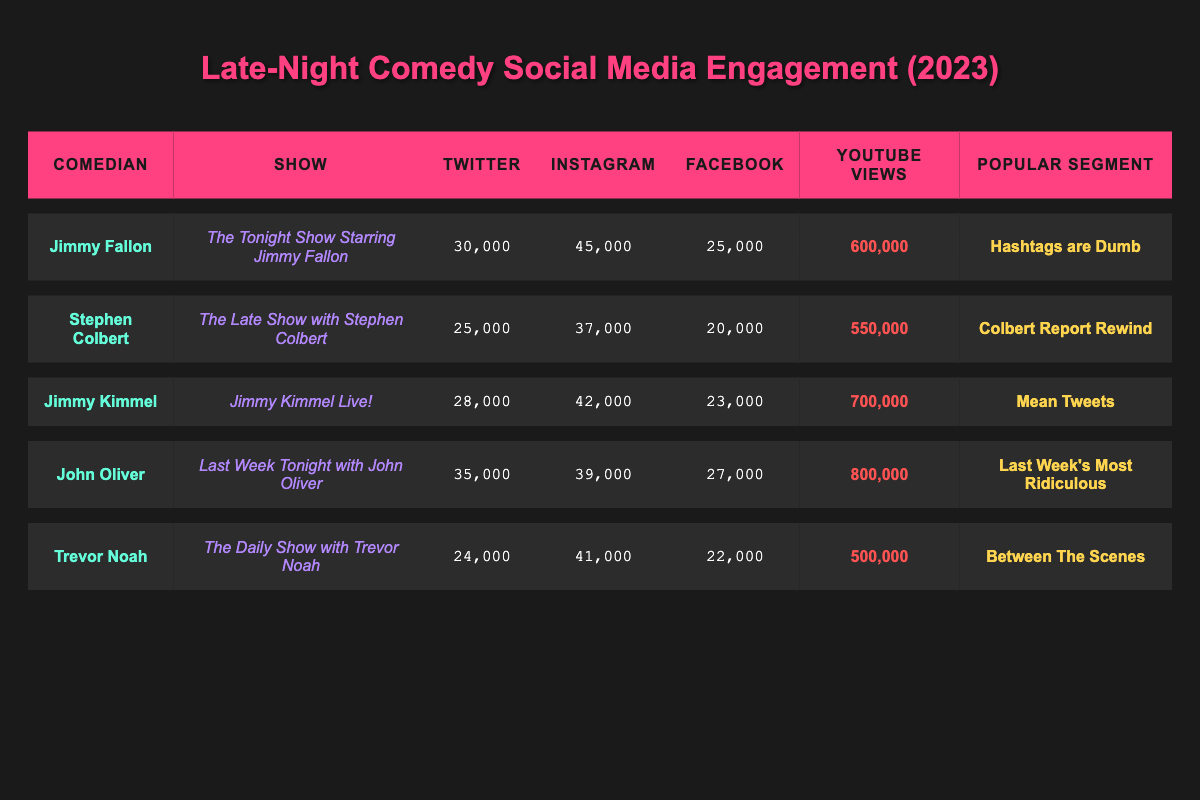What segment had the highest YouTube views? By checking the YouTube views column, John Oliver's segment, "Last Week's Most Ridiculous," has the highest value at 800,000 views, compared to the other segments.
Answer: Last Week's Most Ridiculous Which comedian had the most total social media engagements? To find the total engagements for each comedian, I will sum the Twitter, Instagram, and Facebook engagements. Jimmy Kimmel has 28,000 + 42,000 + 23,000 = 93,000 engagements, John Oliver has 35,000 + 39,000 + 27,000 = 101,000, and Jimmy Fallon has 30,000 + 45,000 + 25,000 = 100,000. Therefore, the maximum total engagements were achieved by John Oliver at 101,000.
Answer: John Oliver Did Trevor Noah have more engagement on Instagram than on Twitter? By comparing Trevor Noah's Instagram engagements of 41,000 to his Twitter engagements of 24,000, it is evident that his Instagram engagement is higher.
Answer: Yes What is the average number of Facebook engagements among these comedians? The total number of Facebook engagements is 25,000 + 20,000 + 23,000 + 27,000 + 22,000 = 117,000. Since there are 5 comedians, calculating the average gives 117,000 / 5 = 23,400.
Answer: 23,400 Which comedian had the least engagement on Facebook? By examining the Facebook engagements, I can see that Trevor Noah has 22,000, which is less than the others: 25,000 by Fallon, 20,000 by Colbert, 23,000 by Kimmel, and 27,000 by Oliver.
Answer: Trevor Noah What is the difference in YouTube views between Jimmy Kimmel's and Stephen Colbert's segments? Checking the YouTube views, Jimmy Kimmel has 700,000 and Stephen Colbert has 550,000. The difference is 700,000 - 550,000 = 150,000.
Answer: 150,000 Which show received the highest Twitter engagement? From the Twitter engagement values, John Oliver's engagement is 35,000, which is higher than the other comedians: Jimmy Fallon has 30,000, Stephen Colbert 25,000, Jimmy Kimmel 28,000, and Trevor Noah 24,000.
Answer: Last Week Tonight with John Oliver Is there any comedian with less than 25,000 total engagements on social media? All comedians have been accounted for, and when looking at the total engagements, Trevor Noah has 22,000 on Facebook and Jim Kimmel and John Oliver have well above that threshold; thus, the answer is No.
Answer: No 